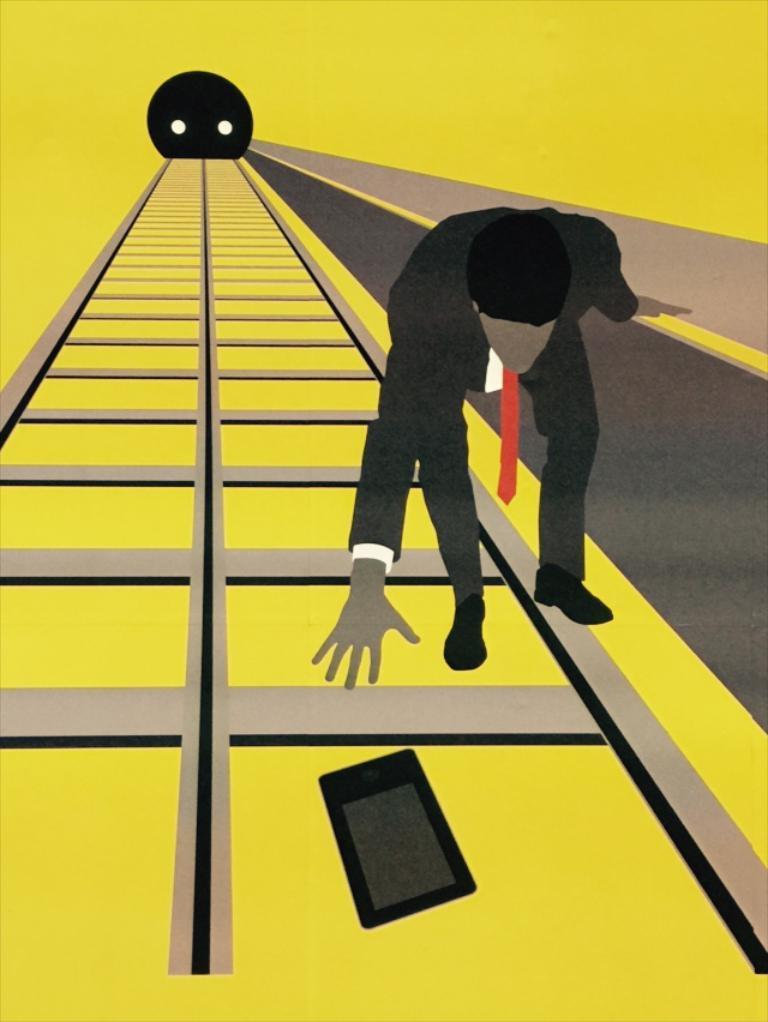What is the main subject of the image? There is a person standing in the image. Can you describe the color of any object in the image? There is an object that is black in color in the image. What type of items can be seen in the image? There are boxes in the image. What type of seed is being planted in harmony with the person in the image? There is no seed or planting activity depicted in the image; it only shows a person standing and an object that is black in color. How many eyes does the person in the image have? The number of eyes the person has cannot be determined from the image alone, as it only shows the person standing and does not provide a close-up view of their face. 